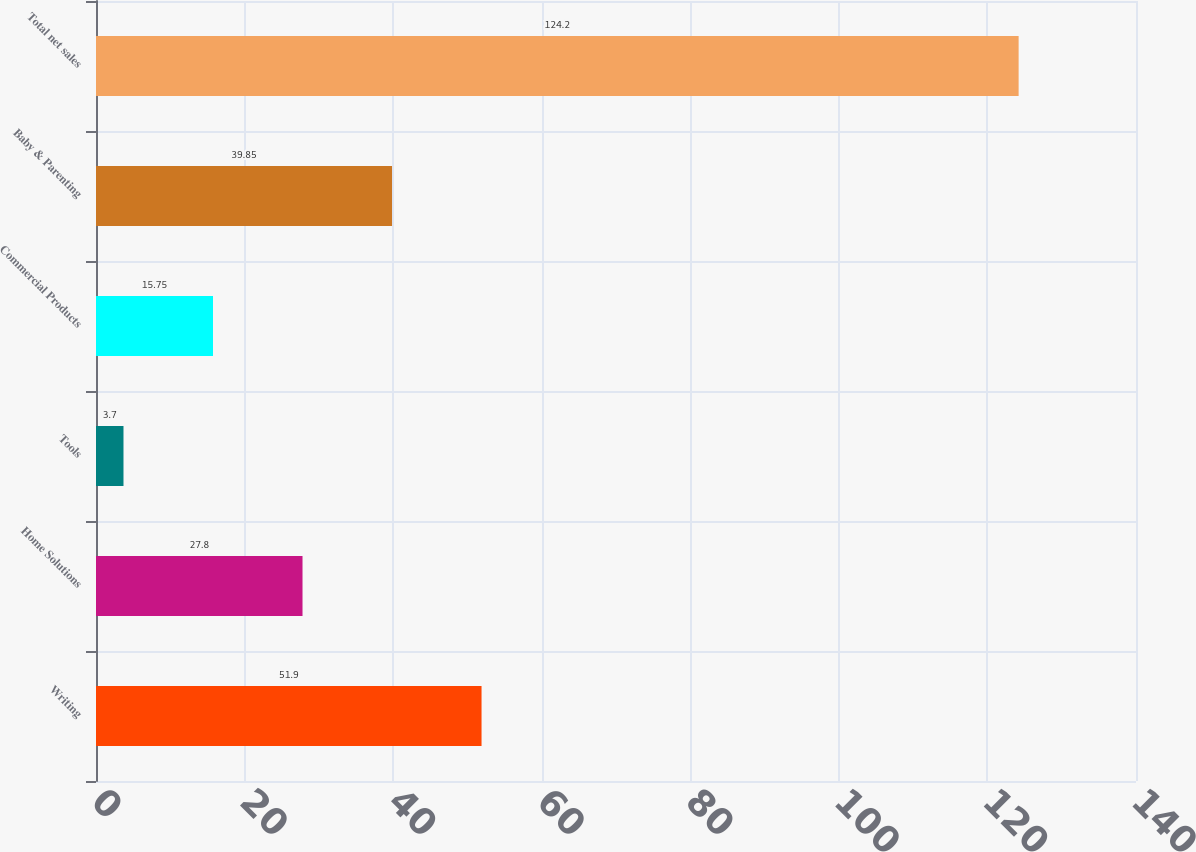Convert chart. <chart><loc_0><loc_0><loc_500><loc_500><bar_chart><fcel>Writing<fcel>Home Solutions<fcel>Tools<fcel>Commercial Products<fcel>Baby & Parenting<fcel>Total net sales<nl><fcel>51.9<fcel>27.8<fcel>3.7<fcel>15.75<fcel>39.85<fcel>124.2<nl></chart> 